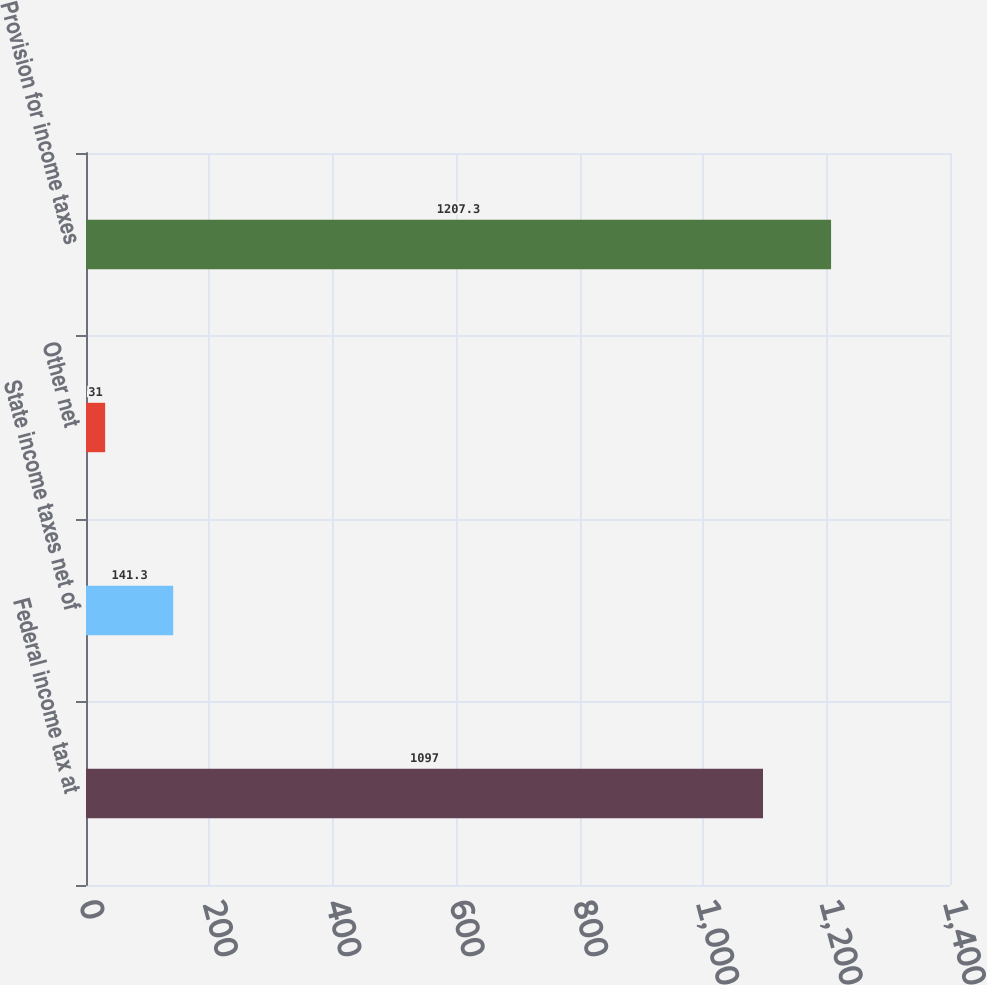Convert chart to OTSL. <chart><loc_0><loc_0><loc_500><loc_500><bar_chart><fcel>Federal income tax at<fcel>State income taxes net of<fcel>Other net<fcel>Provision for income taxes<nl><fcel>1097<fcel>141.3<fcel>31<fcel>1207.3<nl></chart> 